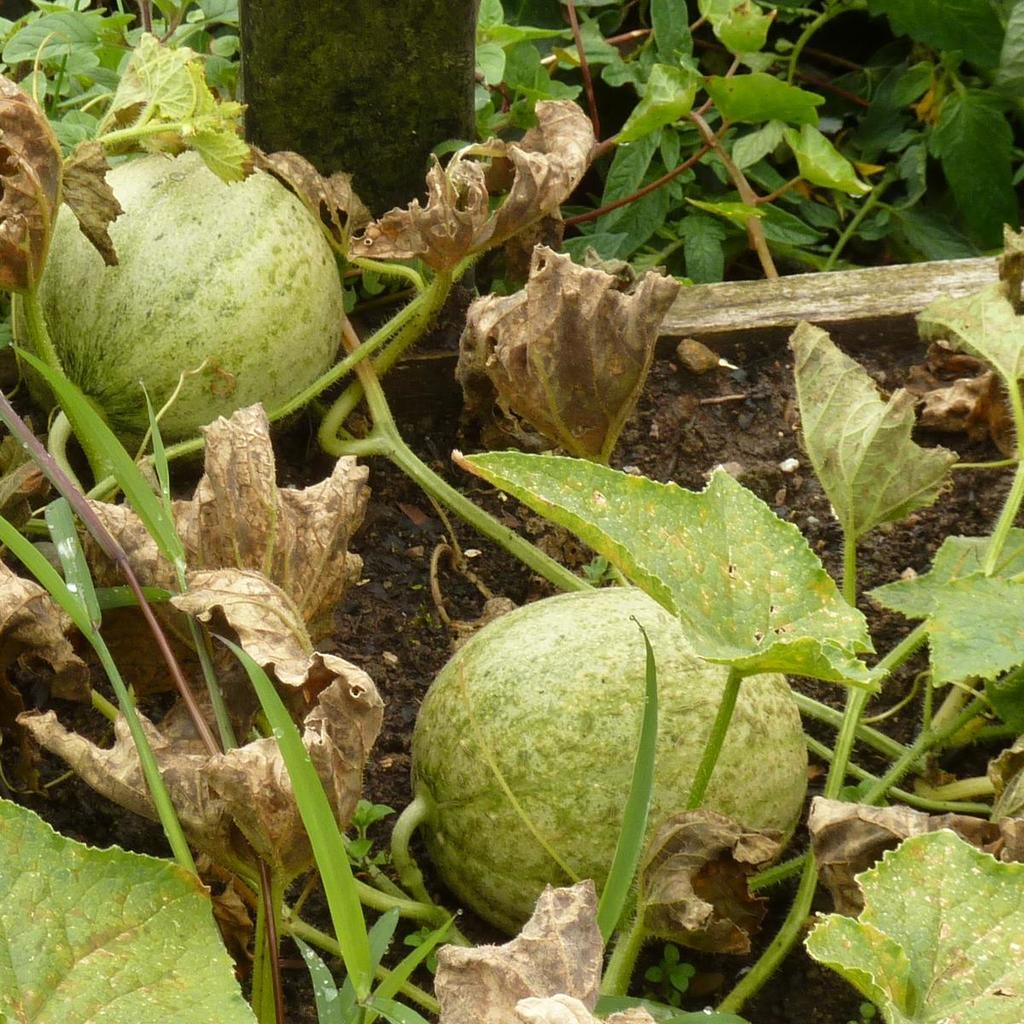What type of vegetables can be seen in the image? There are round and green vegetables in the image. What is the color and type of the tree in the image? The tree in the image is green and brown in color, and it is not specified what type of tree it is. What color is the ground in the image? The ground is visible in the image, and it is brown in color. What type of doll is sitting on the zinc table in the image? There is no doll or zinc table present in the image. 